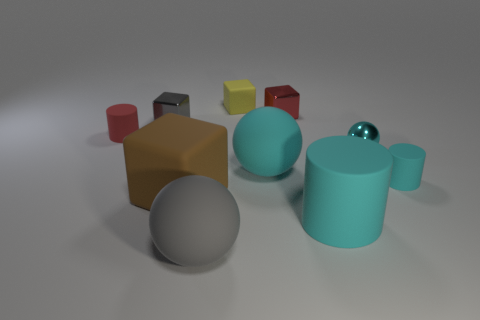Are there more tiny cyan objects on the left side of the small red rubber cylinder than large cyan things behind the metal ball? After closely examining the image, it appears that the number of tiny cyan objects to the left of the small red rubber cylinder is indeed less than that of the large cyan objects behind the metal ball. To provide a precise count, there is one tiny cyan sphere adjacent to the red cylinder, while there are two large cyan containers behind the metal ball. 